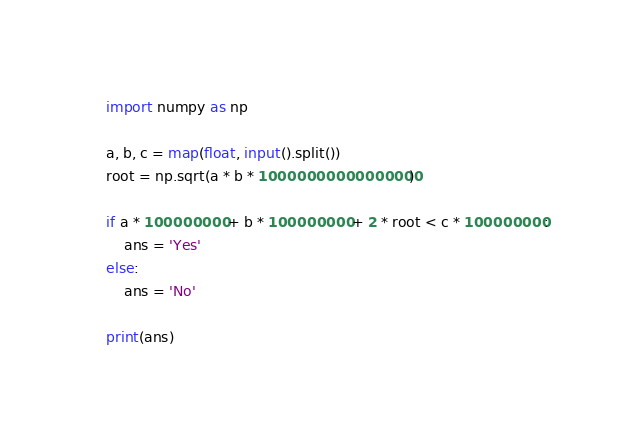Convert code to text. <code><loc_0><loc_0><loc_500><loc_500><_Python_>import numpy as np

a, b, c = map(float, input().split())
root = np.sqrt(a * b * 10000000000000000)

if a * 100000000 + b * 100000000 + 2 * root < c * 100000000:
    ans = 'Yes'
else:
    ans = 'No'

print(ans)</code> 